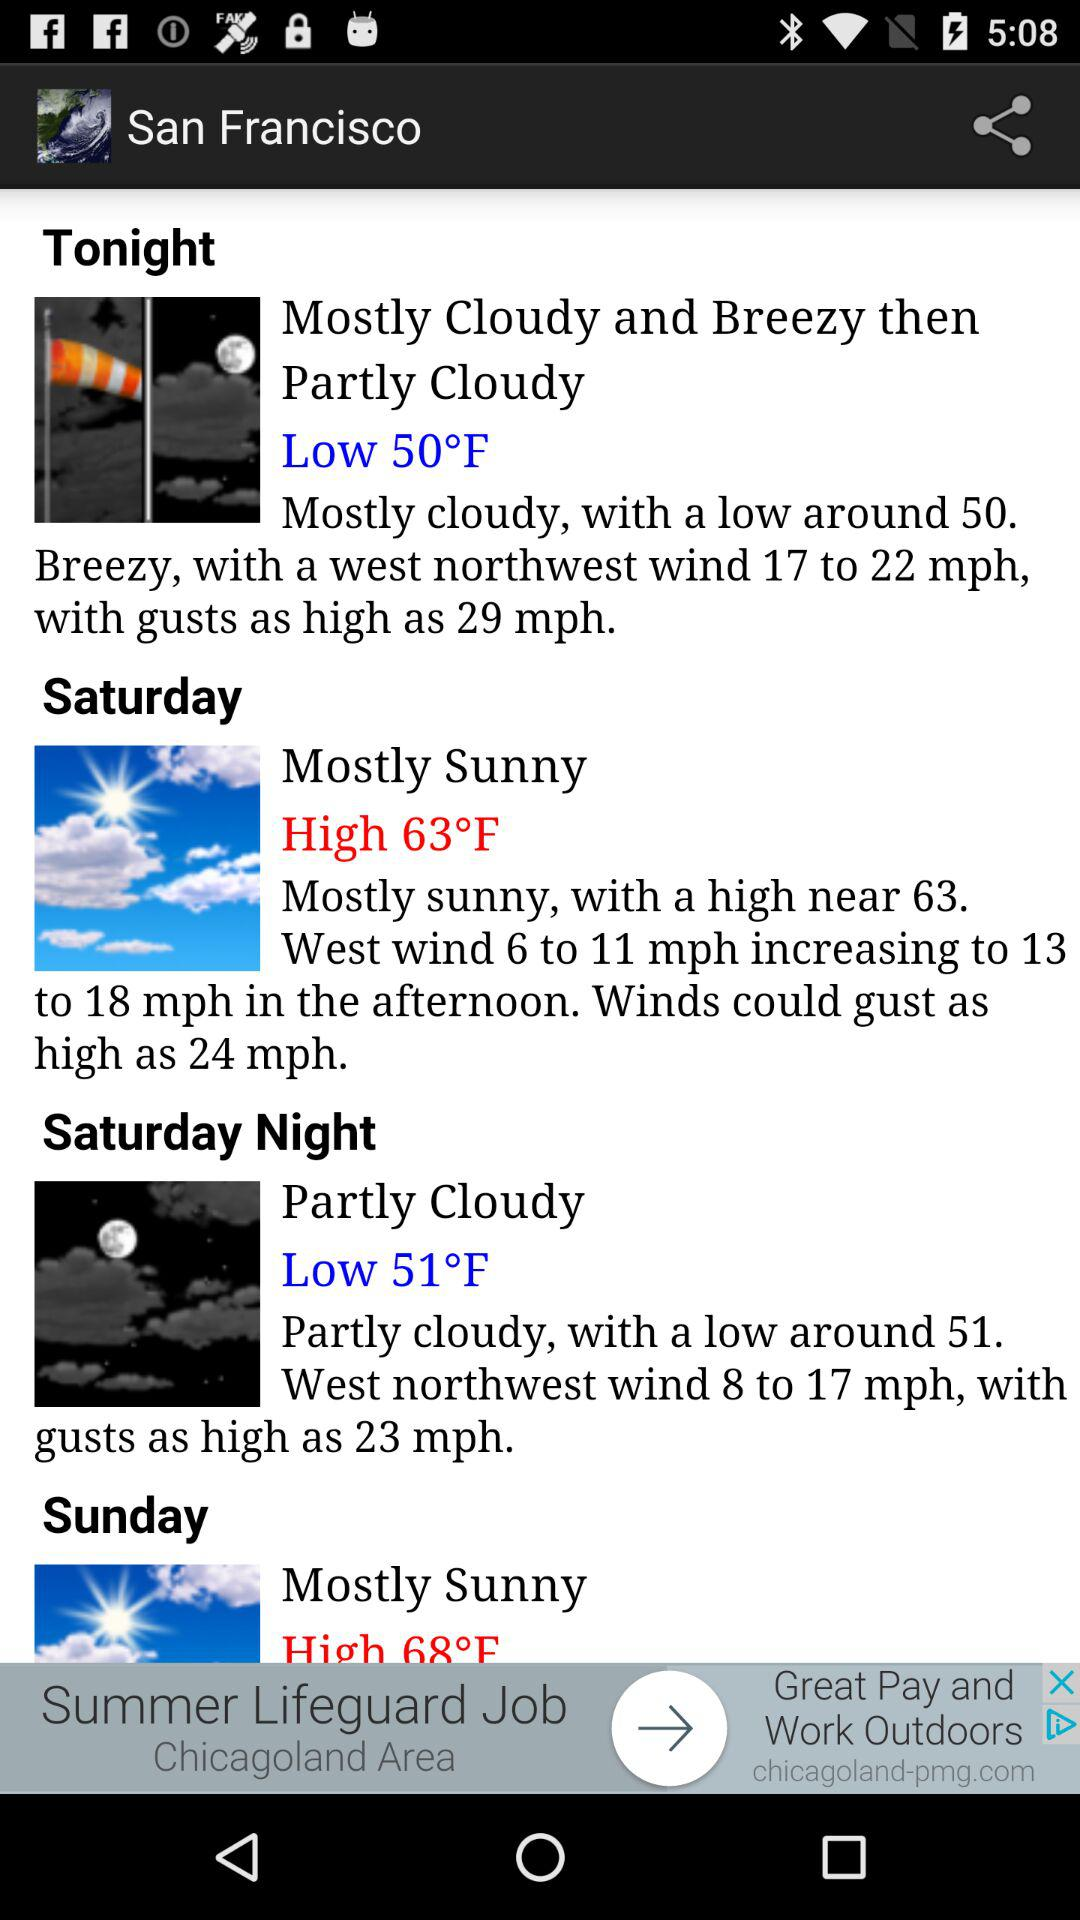How high will the temperature go on Saturday? The temperature on Saturday will reach a high of 63 degrees Fahrenheit. 